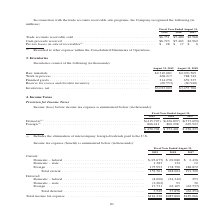According to Jabil Circuit's financial document, What was the current domestic-federal income tax expense (benefit) in 2017? According to the financial document, $2,436 (in thousands). The relevant text states: "rrent: Domestic – federal . $ (23,675) $ 69,080 $ 2,436 Domestic – state . 1,383 134 12 Foreign . 175,993 178,790 188,872..." Also, What was the current domestic-state income tax expense (benefit) in 2019? According to the financial document, 1,383 (in thousands). The relevant text states: ". $ (23,675) $ 69,080 $ 2,436 Domestic – state . 1,383 134 12 Foreign . 175,993 178,790 188,872..." Also, What years does the table provide information for the company's income tax expense (benefit) for? The document contains multiple relevant values: 2019, 2018, 2017. From the document: "2019 2018 2017 2019 2018 2017 2019 2018 2017..." Also, can you calculate: What is the change in the company's domestic-state income tax expense (benefit) between 2018 and 2019? Based on the calculation: 1,383-134, the result is 1249 (in thousands). This is based on the information: "23,675) $ 69,080 $ 2,436 Domestic – state . 1,383 134 12 Foreign . 175,993 178,790 188,872 . $ (23,675) $ 69,080 $ 2,436 Domestic – state . 1,383 134 12 Foreign . 175,993 178,790 188,872..." The key data points involved are: 1,383, 134. Also, can you calculate: What was the change in the company's total current income tax expense (benefit) between 2017 and 2018? Based on the calculation: 248,004-191,320, the result is 56684 (in thousands). This is based on the information: "Total current . 153,701 248,004 191,320 Total current . 153,701 248,004 191,320..." The key data points involved are: 191,320, 248,004. Also, can you calculate: What was the percentage change in the total income tax expense between 2018 and 2019? To answer this question, I need to perform calculations using the financial data. The calculation is: ($161,230-$285,860)/$285,860, which equals -43.6 (percentage). This is based on the information: "Total income tax expense . $161,230 $285,860 $129,066 Total income tax expense . $161,230 $285,860 $129,066..." The key data points involved are: 161,230, 285,860. 